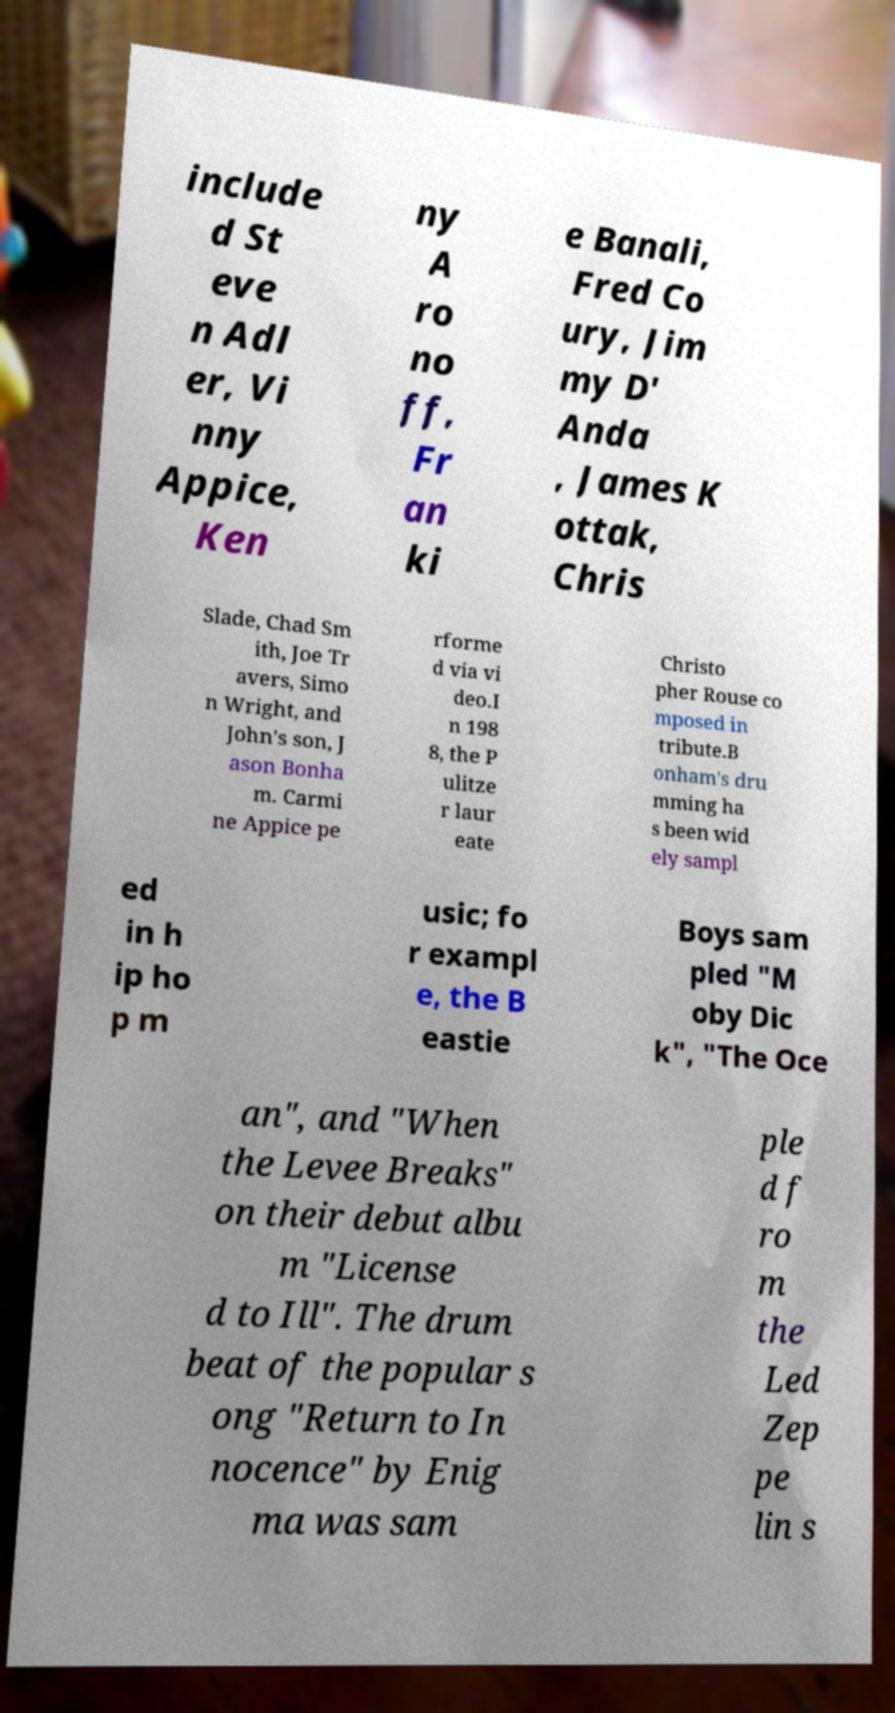Could you extract and type out the text from this image? include d St eve n Adl er, Vi nny Appice, Ken ny A ro no ff, Fr an ki e Banali, Fred Co ury, Jim my D' Anda , James K ottak, Chris Slade, Chad Sm ith, Joe Tr avers, Simo n Wright, and John's son, J ason Bonha m. Carmi ne Appice pe rforme d via vi deo.I n 198 8, the P ulitze r laur eate Christo pher Rouse co mposed in tribute.B onham's dru mming ha s been wid ely sampl ed in h ip ho p m usic; fo r exampl e, the B eastie Boys sam pled "M oby Dic k", "The Oce an", and "When the Levee Breaks" on their debut albu m "License d to Ill". The drum beat of the popular s ong "Return to In nocence" by Enig ma was sam ple d f ro m the Led Zep pe lin s 